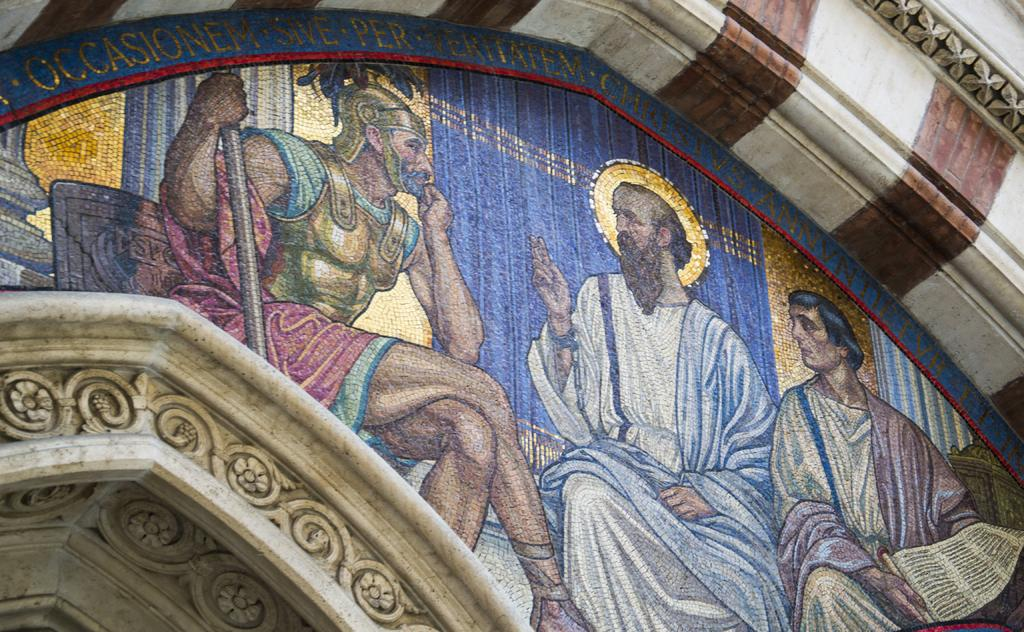What is depicted on the building in the image? There is a painting on a building in the image. How many people are sitting in the image? There are three persons sitting in the image. What type of ghost can be seen interacting with the banana in the image? There is no ghost or banana present in the image; it features a painting on a building and three persons sitting. 